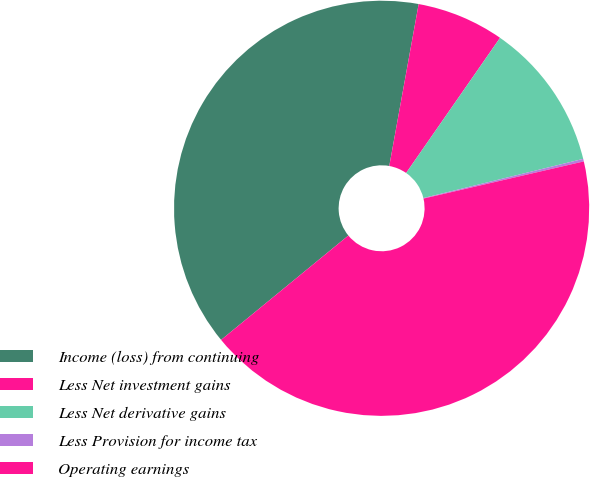Convert chart to OTSL. <chart><loc_0><loc_0><loc_500><loc_500><pie_chart><fcel>Income (loss) from continuing<fcel>Less Net investment gains<fcel>Less Net derivative gains<fcel>Less Provision for income tax<fcel>Operating earnings<nl><fcel>38.79%<fcel>6.81%<fcel>11.51%<fcel>0.2%<fcel>42.7%<nl></chart> 